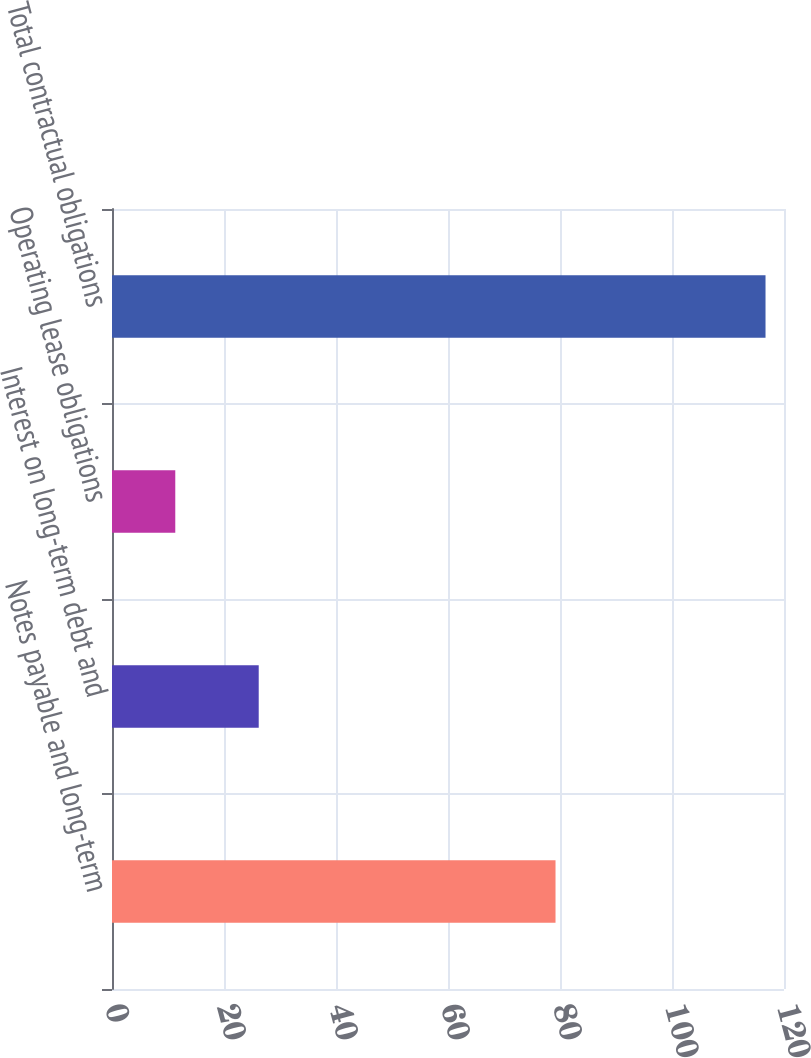<chart> <loc_0><loc_0><loc_500><loc_500><bar_chart><fcel>Notes payable and long-term<fcel>Interest on long-term debt and<fcel>Operating lease obligations<fcel>Total contractual obligations<nl><fcel>79.2<fcel>26.2<fcel>11.3<fcel>116.7<nl></chart> 